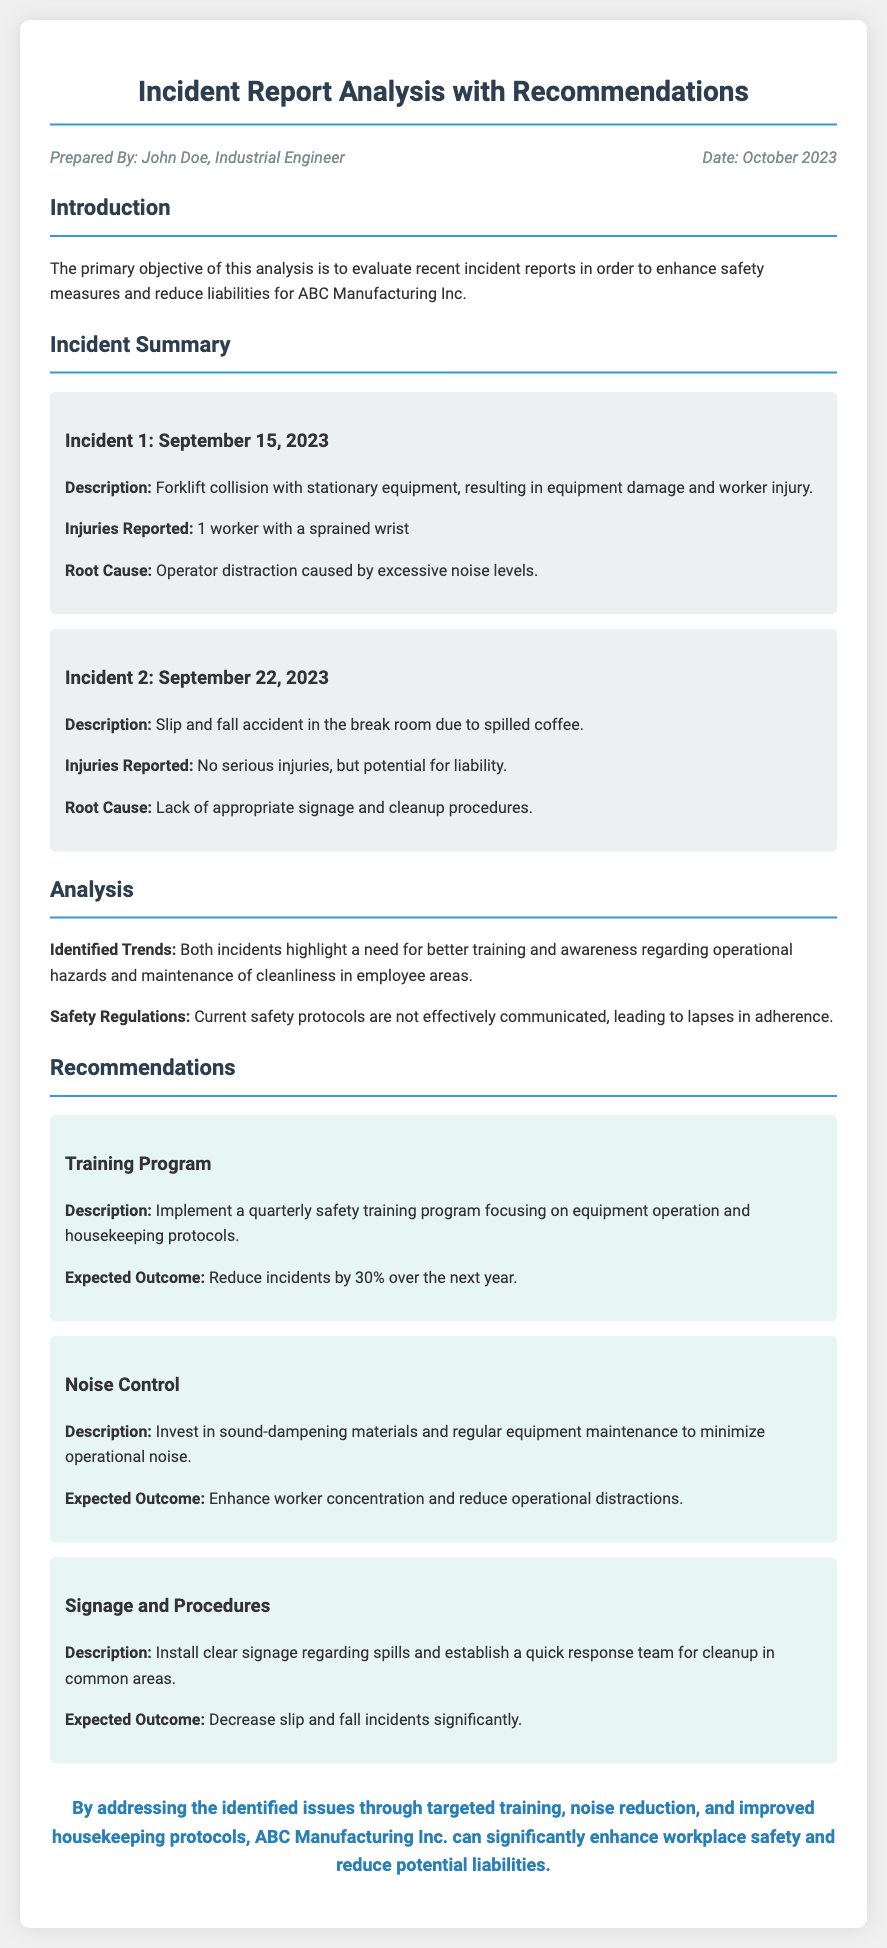What is the primary objective of the analysis? The primary objective is to enhance safety measures and reduce liabilities for ABC Manufacturing Inc.
Answer: Enhance safety measures and reduce liabilities Who prepared the report? The report was prepared by John Doe, an Industrial Engineer.
Answer: John Doe What were the injuries reported in Incident 1? In Incident 1, 1 worker suffered a sprained wrist.
Answer: 1 worker with a sprained wrist What is one of the identified trends in the analysis? The identified trend highlights a need for better training and awareness regarding operational hazards.
Answer: Better training and awareness regarding operational hazards How often should the safety training program be implemented? The safety training program should be implemented quarterly.
Answer: Quarterly What type of materials should be invested in to minimize operational noise? Investing in sound-dampening materials is recommended.
Answer: Sound-dampening materials What is the expected outcome of implementing a quarterly safety training program? The expected outcome is to reduce incidents by 30% over the next year.
Answer: Reduce incidents by 30% What is one action recommended for improving safety in common areas? One recommendation is to install clear signage regarding spills.
Answer: Install clear signage regarding spills Which incident occurred on September 22, 2023? The slip and fall accident in the break room due to spilled coffee occurred on that date.
Answer: Slip and fall accident in the break room due to spilled coffee 